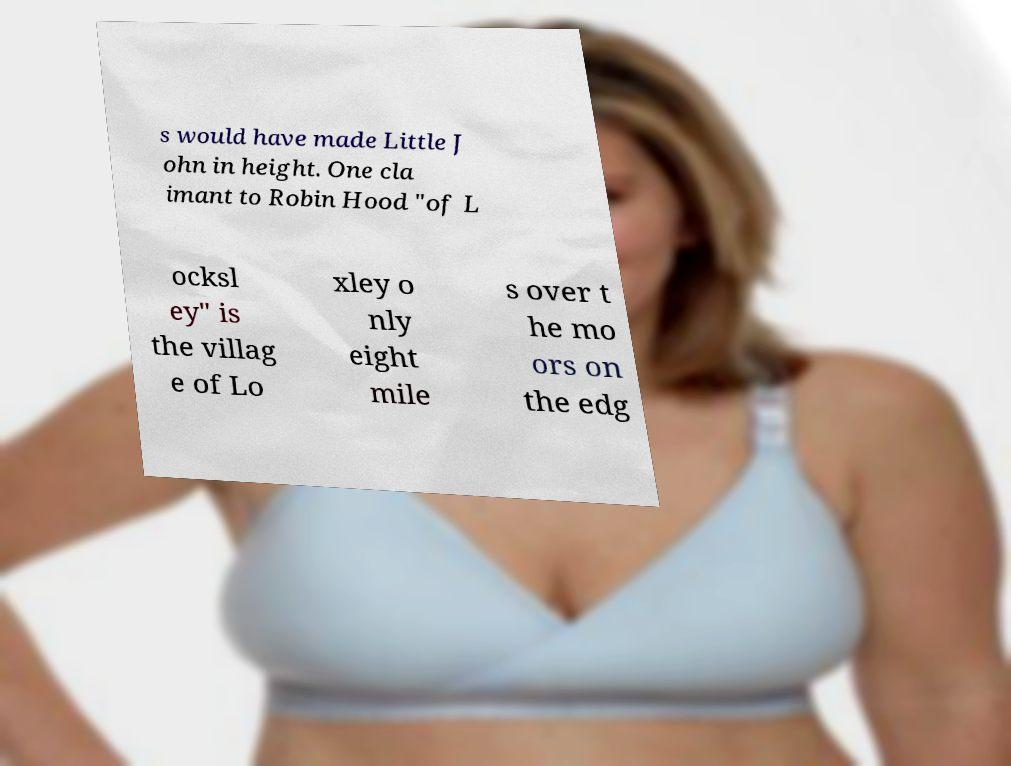Can you read and provide the text displayed in the image?This photo seems to have some interesting text. Can you extract and type it out for me? s would have made Little J ohn in height. One cla imant to Robin Hood "of L ocksl ey" is the villag e of Lo xley o nly eight mile s over t he mo ors on the edg 